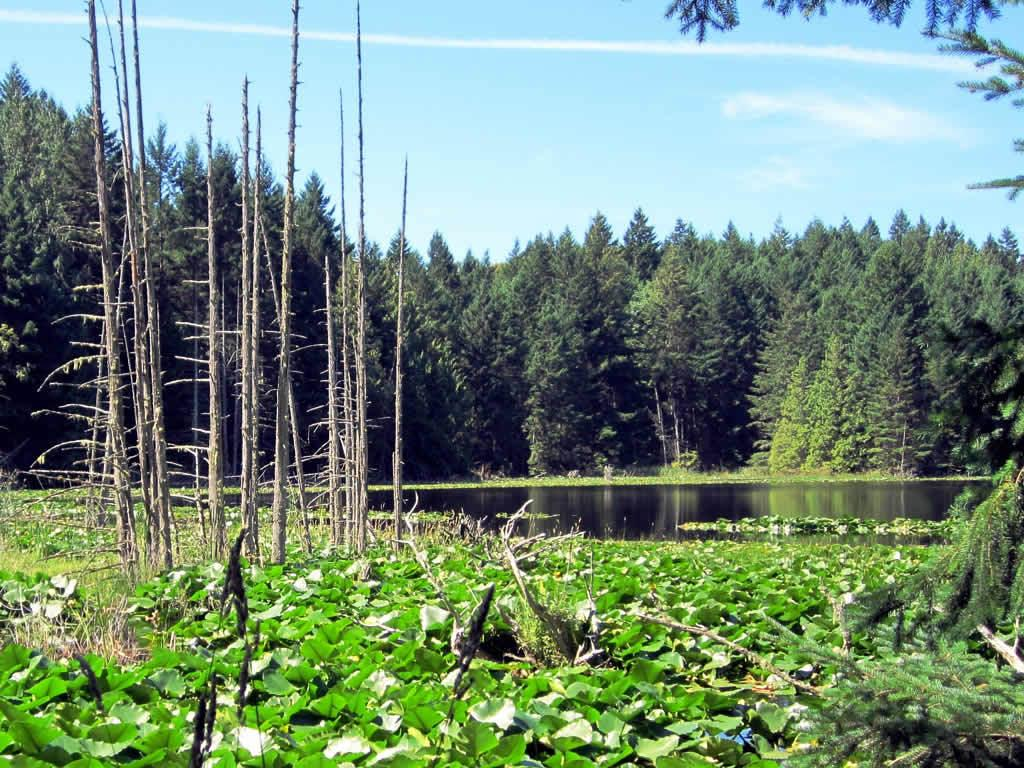What is the primary element visible in the image? There is water in the image. What type of vegetation can be seen in the image? There are trees in the image. What can be seen in the background of the image? The sky is visible in the background of the image. What is the condition of the sky in the image? Clouds are present in the sky. What type of coach can be seen driving through the water in the image? There is no coach present in the image; it features water, trees, and a sky with clouds. Can you tell me how many owls are perched on the trees in the image? There are no owls present in the image; it features trees and a sky with clouds. 